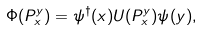Convert formula to latex. <formula><loc_0><loc_0><loc_500><loc_500>\Phi ( P _ { x } ^ { y } ) = { \psi } ^ { \dagger } ( x ) U ( P _ { x } ^ { y } ) \psi ( y ) ,</formula> 